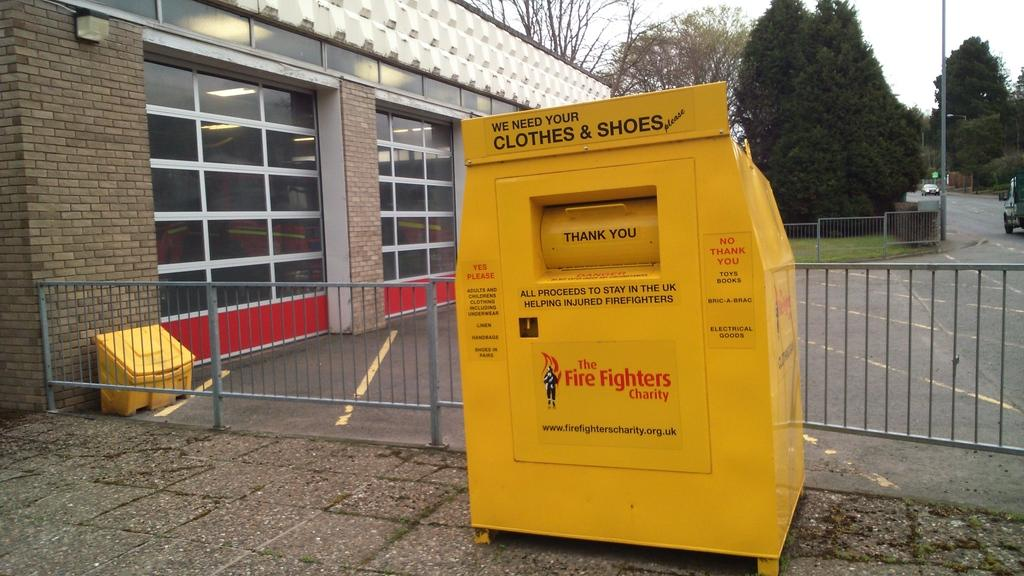What is the main object in the image? There is a charity box in the image. Can you describe any other objects in the image? There is an object in the image, but its specific details are not mentioned. What can be seen on the road in the image? Vehicles are visible on the road in the image. What type of structures are present in the image? There are poles and at least one building in the image. What type of natural elements are present in the image? Trees are present in the image. What is visible in the background of the image? The sky is visible in the background of the image. What type of trade is being conducted in the image? There is no indication of any trade being conducted in the image. The image primarily features a charity box, vehicles, and other elements. 